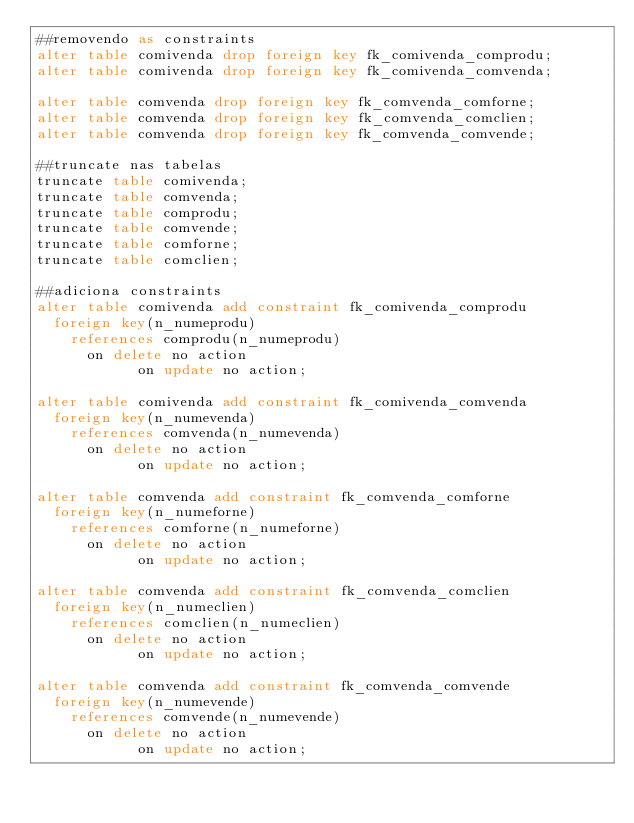Convert code to text. <code><loc_0><loc_0><loc_500><loc_500><_SQL_>##removendo as constraints
alter table comivenda drop foreign key fk_comivenda_comprodu;
alter table comivenda drop foreign key fk_comivenda_comvenda;

alter table comvenda drop foreign key fk_comvenda_comforne;
alter table comvenda drop foreign key fk_comvenda_comclien;
alter table comvenda drop foreign key fk_comvenda_comvende;

##truncate nas tabelas
truncate table comivenda;
truncate table comvenda;
truncate table comprodu;
truncate table comvende;
truncate table comforne;
truncate table comclien;

##adiciona constraints
alter table comivenda add constraint fk_comivenda_comprodu
	foreign key(n_numeprodu)
		references comprodu(n_numeprodu) 
			on delete no action
            on update no action;

alter table comivenda add constraint fk_comivenda_comvenda
	foreign key(n_numevenda)
		references comvenda(n_numevenda)
			on delete no action
            on update no action;

alter table comvenda add constraint fk_comvenda_comforne
	foreign key(n_numeforne)
		references comforne(n_numeforne)
			on delete no action
            on update no action;

alter table comvenda add constraint fk_comvenda_comclien
	foreign key(n_numeclien)
		references comclien(n_numeclien)
			on delete no action
            on update no action;

alter table comvenda add constraint fk_comvenda_comvende
	foreign key(n_numevende)
		references comvende(n_numevende)
			on delete no action
            on update no action;
            

            
</code> 